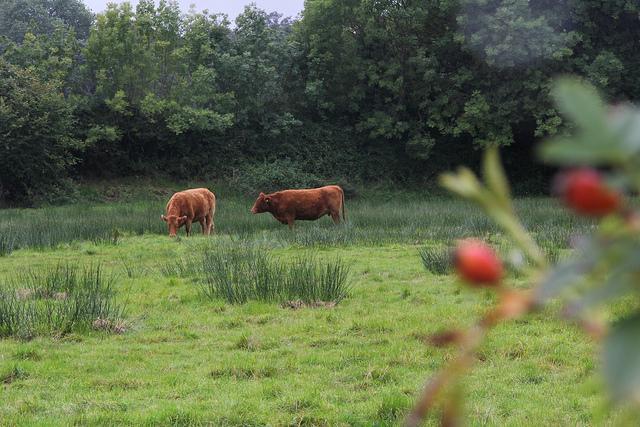How many cows have their heads down eating grass?
Give a very brief answer. 1. How many person is wearing orange color t-shirt?
Give a very brief answer. 0. 